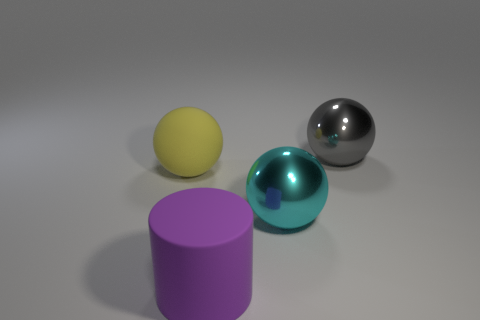Subtract all large cyan spheres. How many spheres are left? 2 Add 4 big yellow spheres. How many objects exist? 8 Subtract all balls. How many objects are left? 1 Add 2 balls. How many balls are left? 5 Add 4 red matte balls. How many red matte balls exist? 4 Subtract 0 green balls. How many objects are left? 4 Subtract all green rubber spheres. Subtract all big things. How many objects are left? 0 